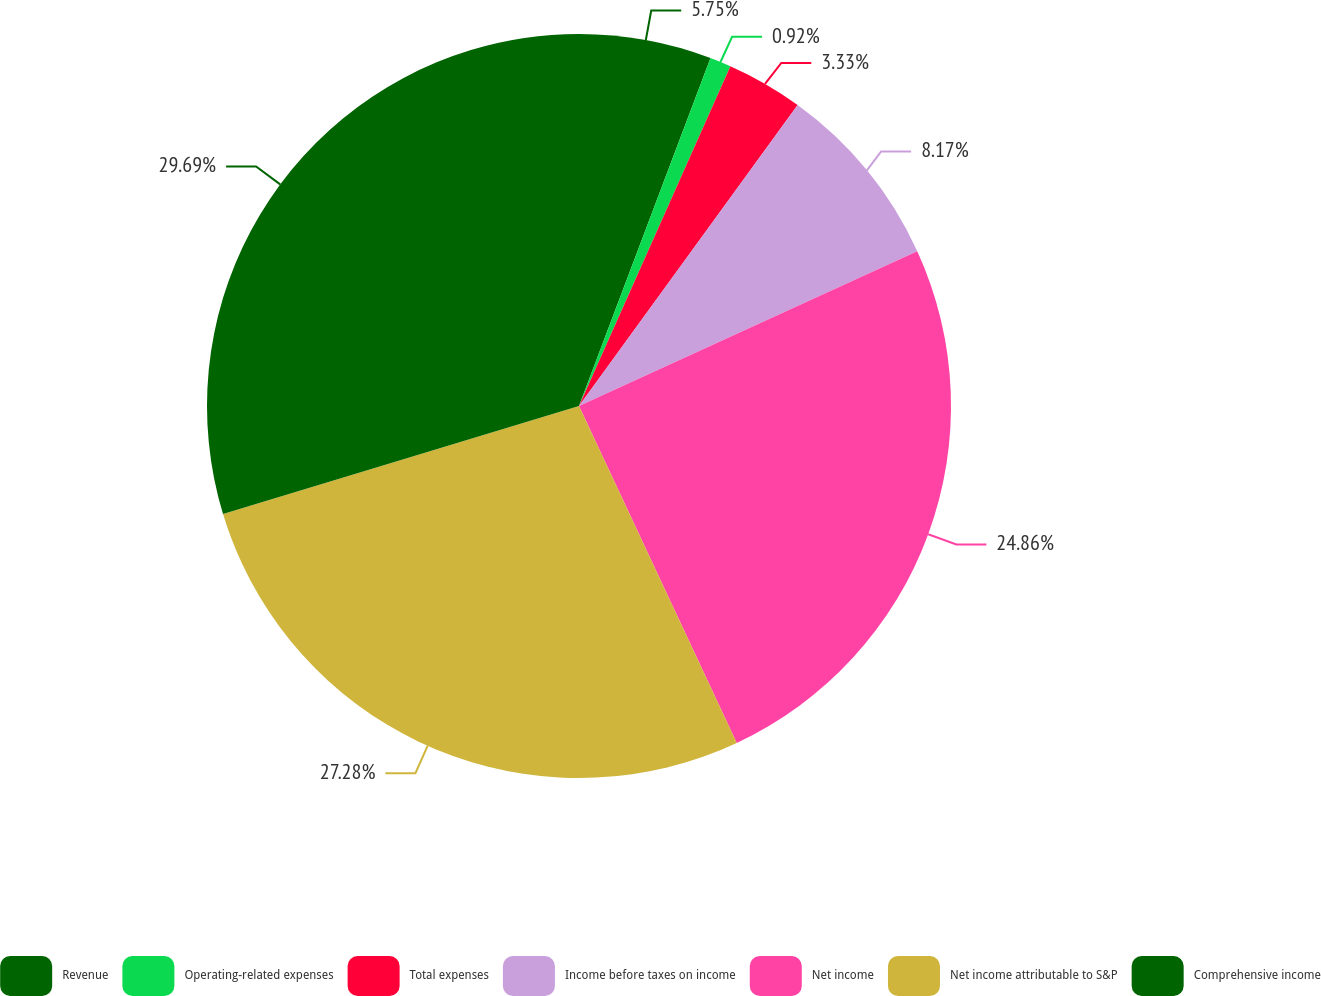Convert chart to OTSL. <chart><loc_0><loc_0><loc_500><loc_500><pie_chart><fcel>Revenue<fcel>Operating-related expenses<fcel>Total expenses<fcel>Income before taxes on income<fcel>Net income<fcel>Net income attributable to S&P<fcel>Comprehensive income<nl><fcel>5.75%<fcel>0.92%<fcel>3.33%<fcel>8.17%<fcel>24.86%<fcel>27.28%<fcel>29.69%<nl></chart> 